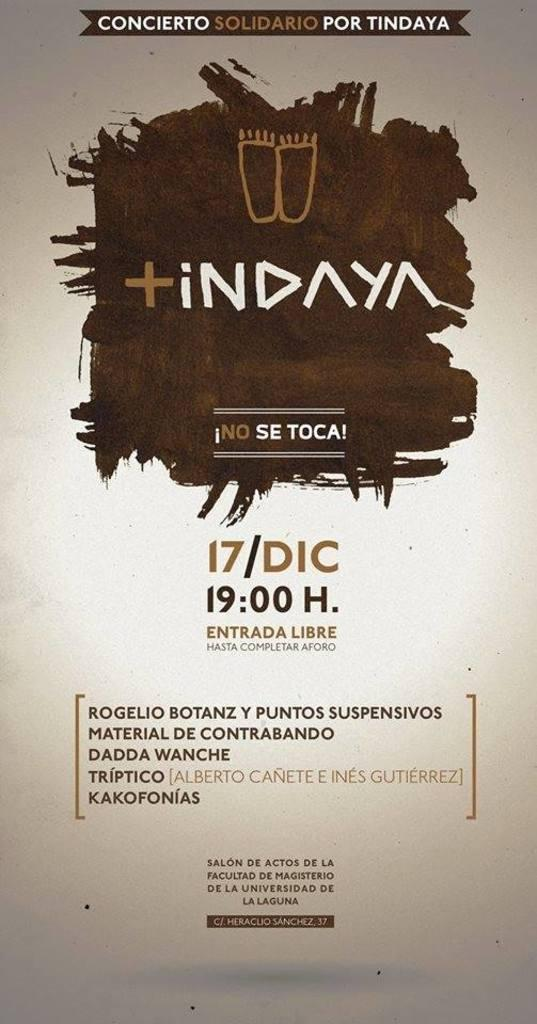Provide a one-sentence caption for the provided image. According to its poster, an advertised event takes place at 19:00 H. 